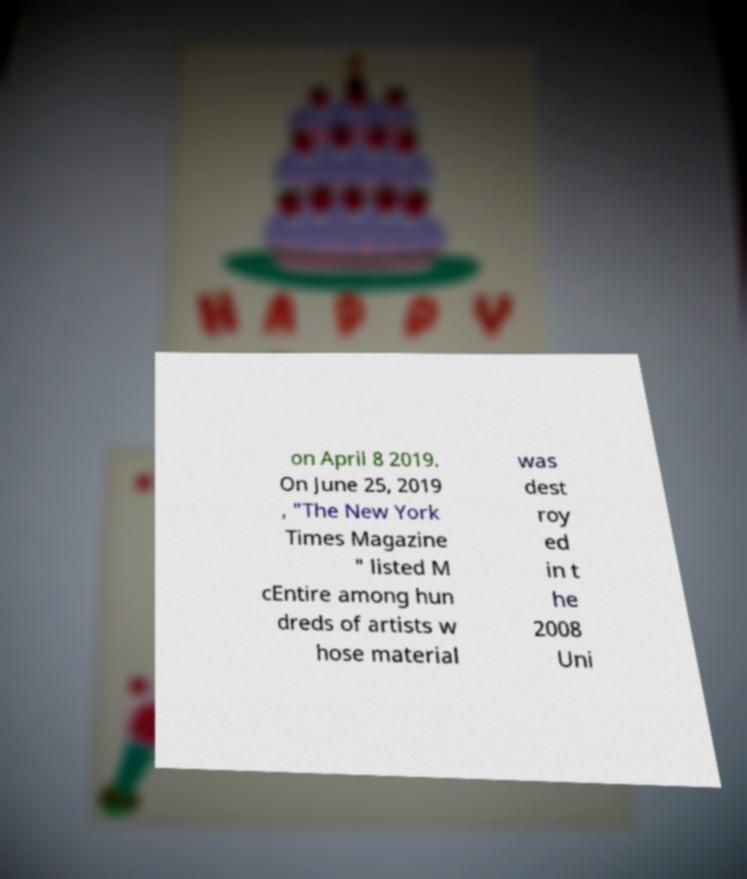Could you assist in decoding the text presented in this image and type it out clearly? on April 8 2019. On June 25, 2019 , "The New York Times Magazine " listed M cEntire among hun dreds of artists w hose material was dest roy ed in t he 2008 Uni 